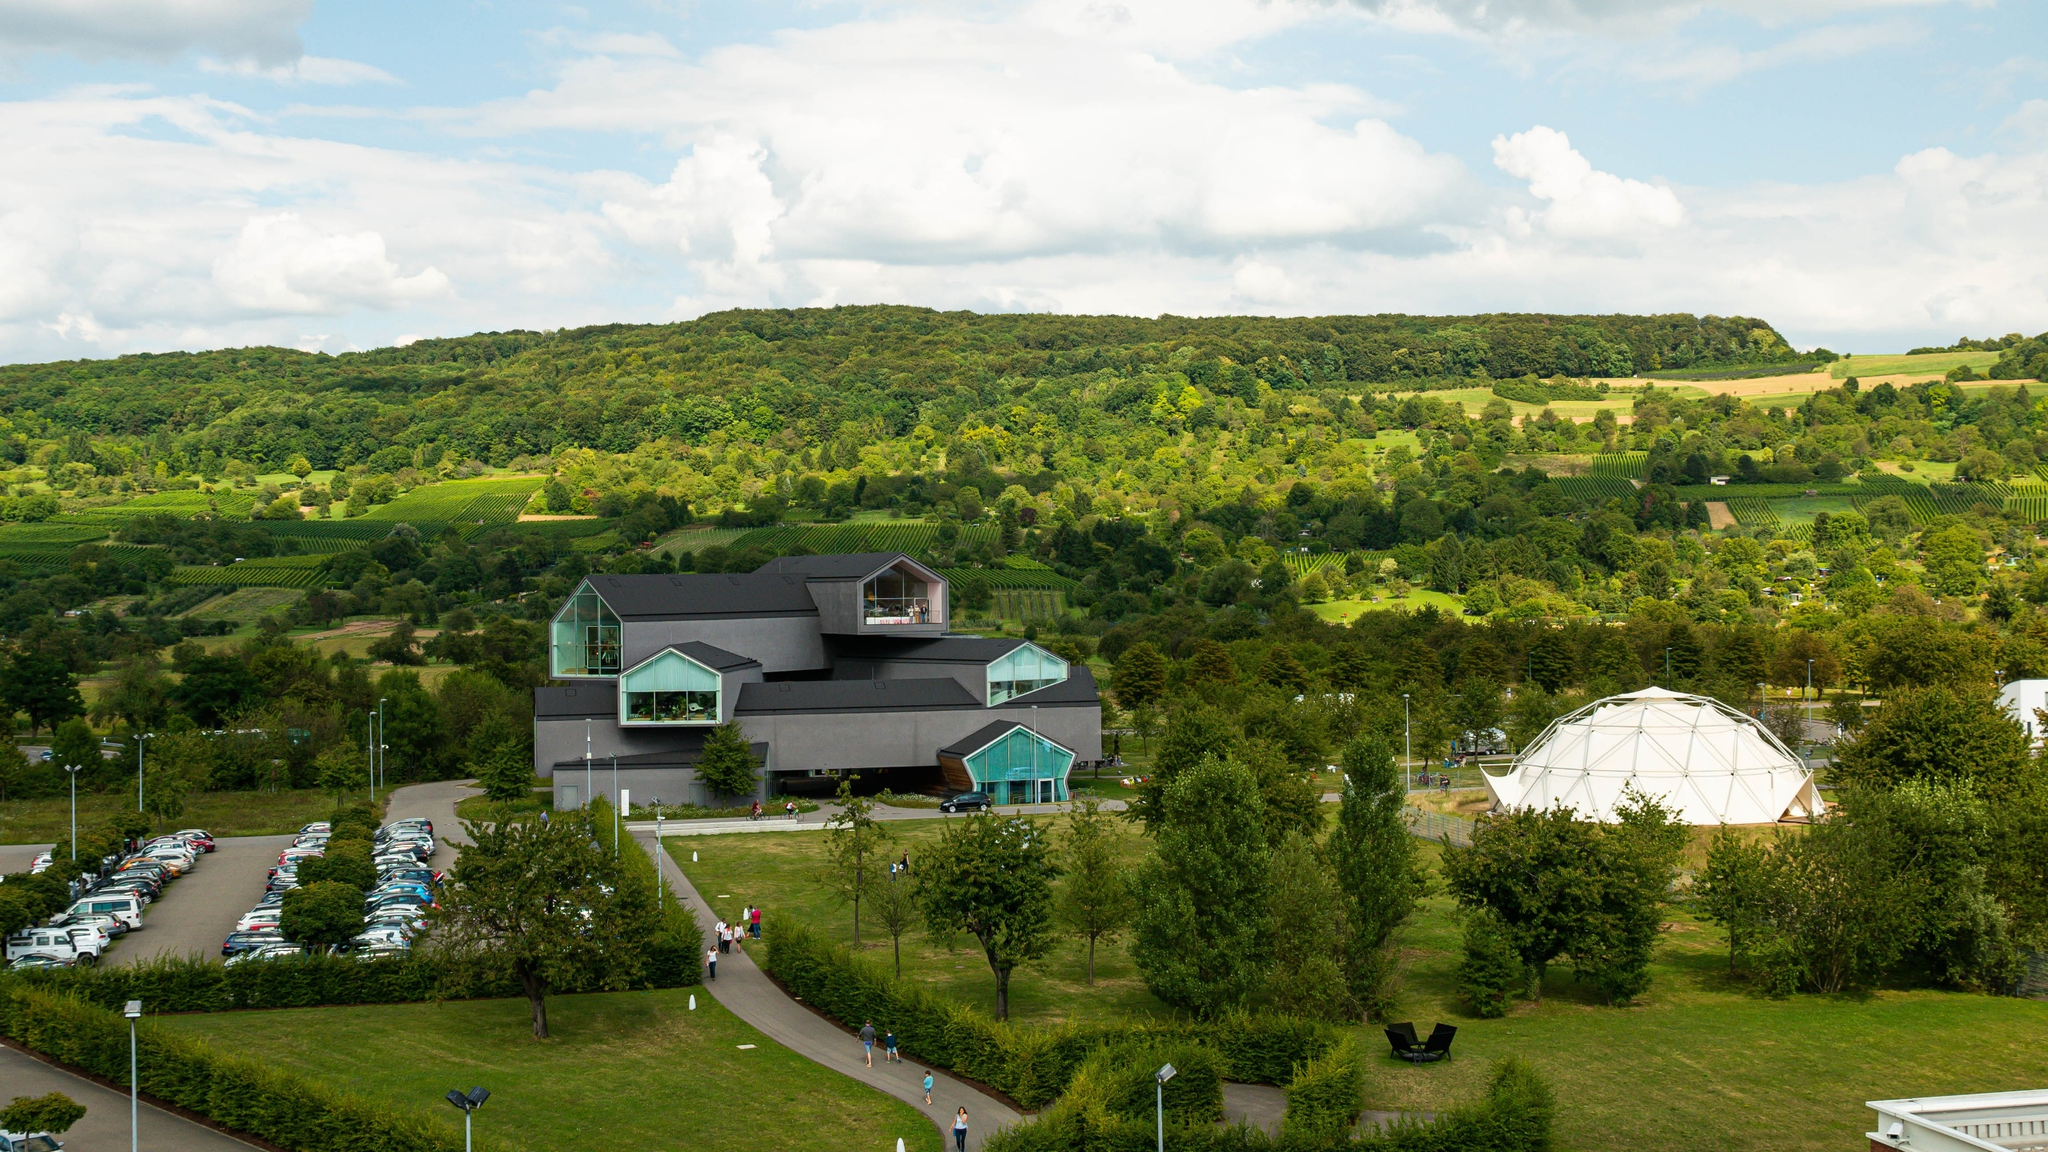Imagine if the museum could transform into an animal. What animal would it turn into and why? If the Vitra Design Museum were to transform into an animal, it might become a majestic black panther. Just like the museum, a black panther is sleek, elegant, and has an aura of mystery. Its sharp, angular forms could be reminiscent of the triangular windows of the museum, while the overall black exterior would match the panther’s deep, inky fur. This transformation would symbolize a blend of beauty, grace, and power, echoing the museum’s striking presence amid the natural landscape. What exhibits might the panther-museum house if it could move through the forest and collect nature artifacts? If the panther-museum could roam through the forest and collect nature artifacts, it might house an eclectic mix of natural wonders. One exhibit could feature rare, colorful feathers from exotic birds, displayed in a vibrant, artistic manner. Another section might showcase intricate nests built by various forest creatures, highlighting their architectural ingenuity. The museum could also have a collection of unique leaves and flowers arranged in beautiful patterns, offering a sensory experience through the textures and fragrances of the forest. Additionally, the panther-museum might present a digital exhibit of the changing seasons, providing visitors with an immersive experience of the natural world’s dynamic beauty. 